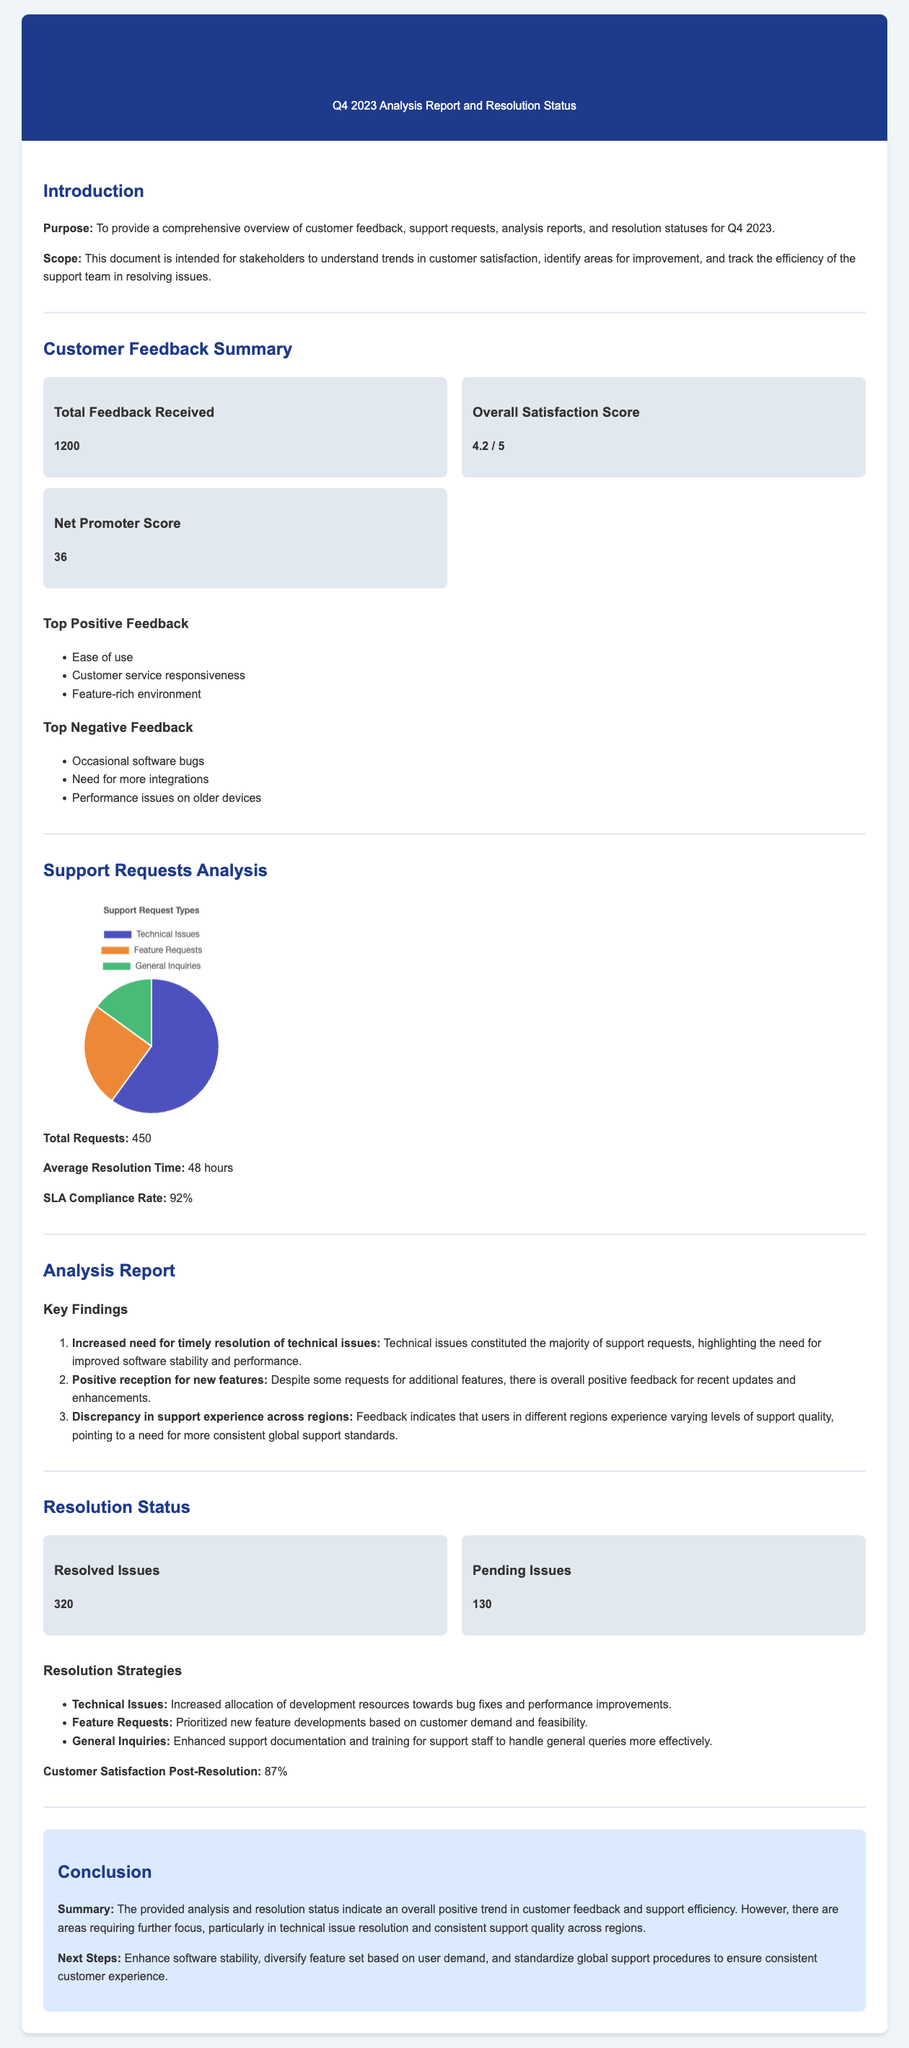What is the total feedback received? The total feedback received is a metric presented in the document summarizing customer interactions.
Answer: 1200 What is the overall satisfaction score? The overall satisfaction score reflects customer contentment as indicated in the metrics section of the document.
Answer: 4.2 / 5 What percentage of support requests were technical issues? The distribution of support requests indicates the percentage of technical issues out of the total.
Answer: 60 What is the average resolution time for support requests? The average resolution time statistic is provided to show how quickly issues are typically resolved.
Answer: 48 hours What is the Net Promoter Score? The Net Promoter Score is a key performance indicator for customer loyalty presented in the document.
Answer: 36 How many resolved issues are reported? The number of resolved issues is a key metric in the resolution status section of the document.
Answer: 320 What is the customer satisfaction score post-resolution? The customer satisfaction score after issues have been resolved is highlighted to reflect the effectiveness of resolutions.
Answer: 87% What is the SLA compliance rate? The SLA compliance rate indicates how well the support team is meeting service level agreements.
Answer: 92% Which type of feedback was ranked the highest as positive? The positive feedback ratings provide insight into customer favorability in specific areas.
Answer: Ease of use 